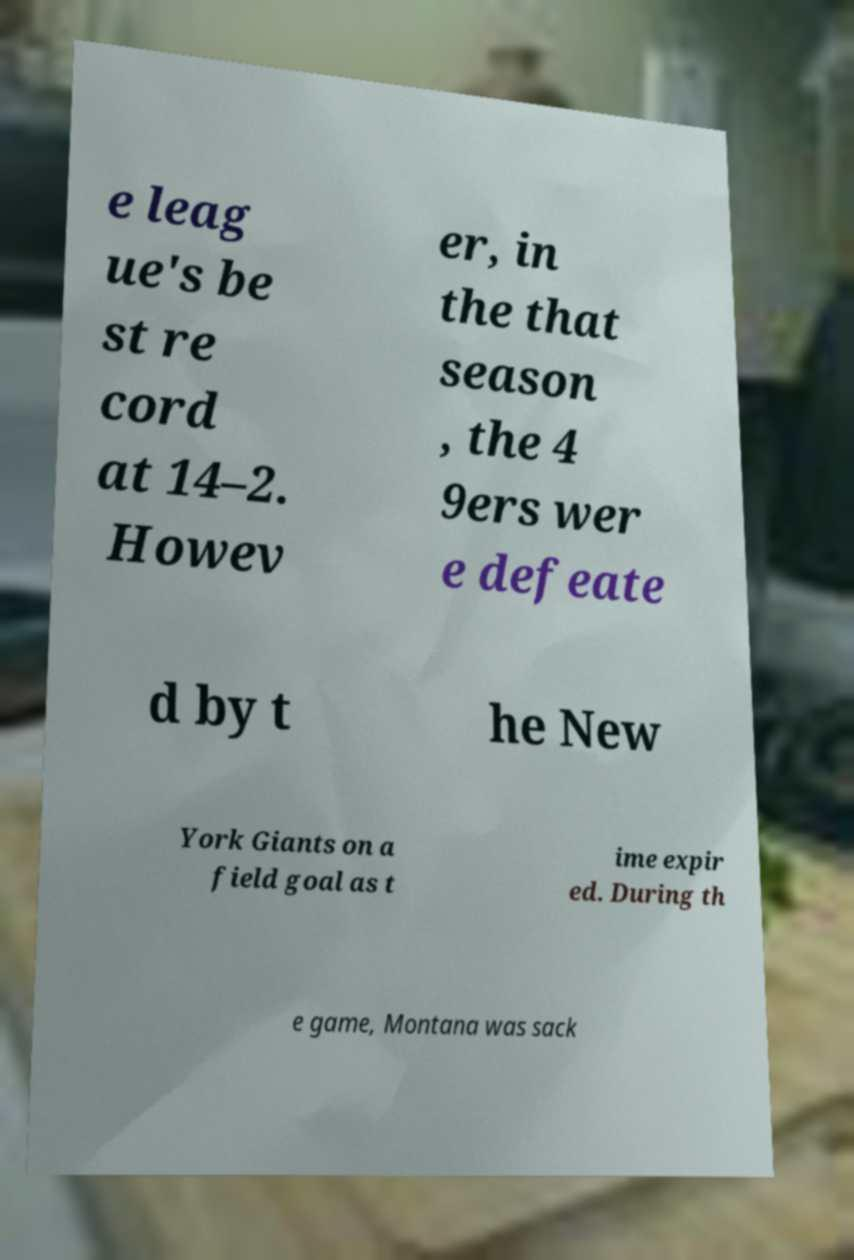Can you read and provide the text displayed in the image?This photo seems to have some interesting text. Can you extract and type it out for me? e leag ue's be st re cord at 14–2. Howev er, in the that season , the 4 9ers wer e defeate d by t he New York Giants on a field goal as t ime expir ed. During th e game, Montana was sack 